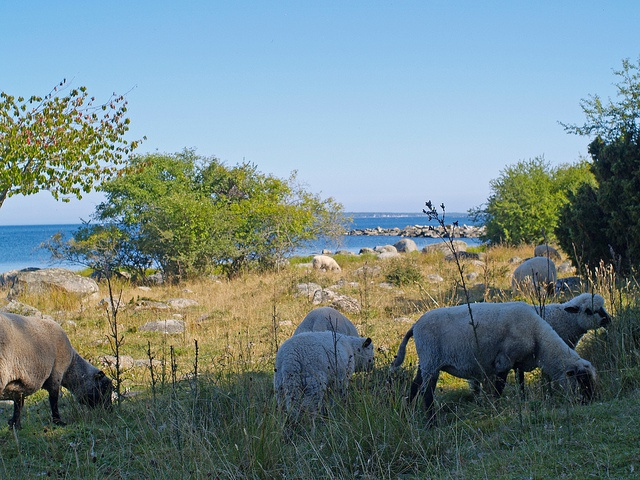Describe the objects in this image and their specific colors. I can see sheep in lightblue, black, blue, and navy tones, sheep in lightblue, black, gray, and tan tones, sheep in lightblue, gray, blue, and black tones, sheep in lightblue, black, blue, darkblue, and gray tones, and sheep in lightblue, gray, and blue tones in this image. 